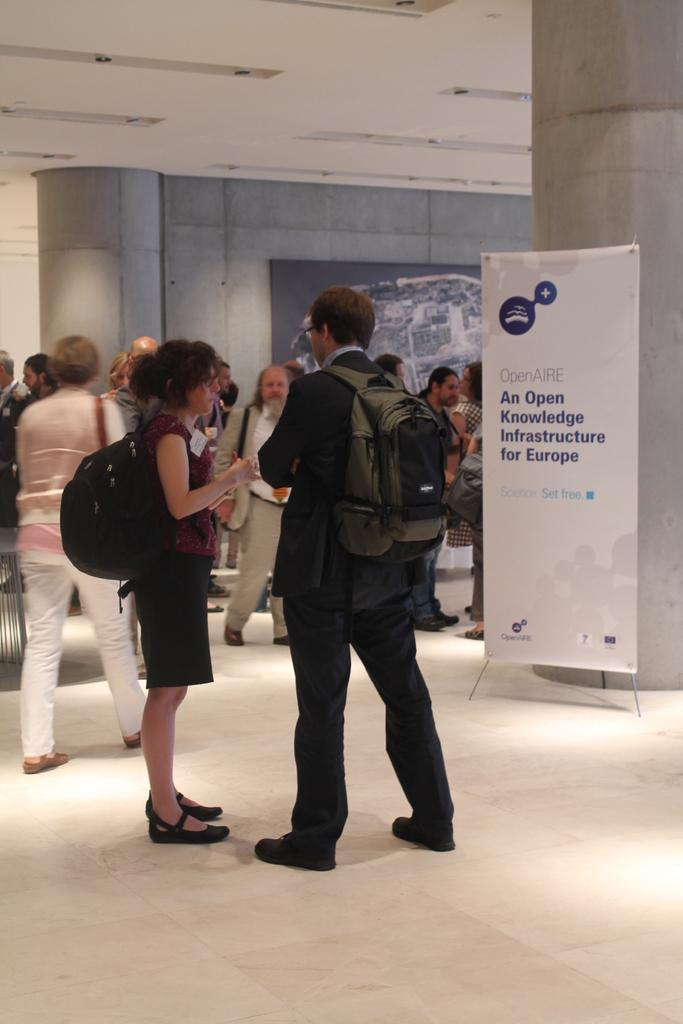What are the people in the image doing? The people in the image are standing in the center. What are the people wearing on their backs? The people are wearing backpacks. What can be seen in the background of the image? There is a wallboard, a pillar, and a banner in the background. What type of straw is being used by the beetle in the image? There is no beetle or straw present in the image. How does the wind affect the banner in the image? The image does not show any movement or effects of wind on the banner. 